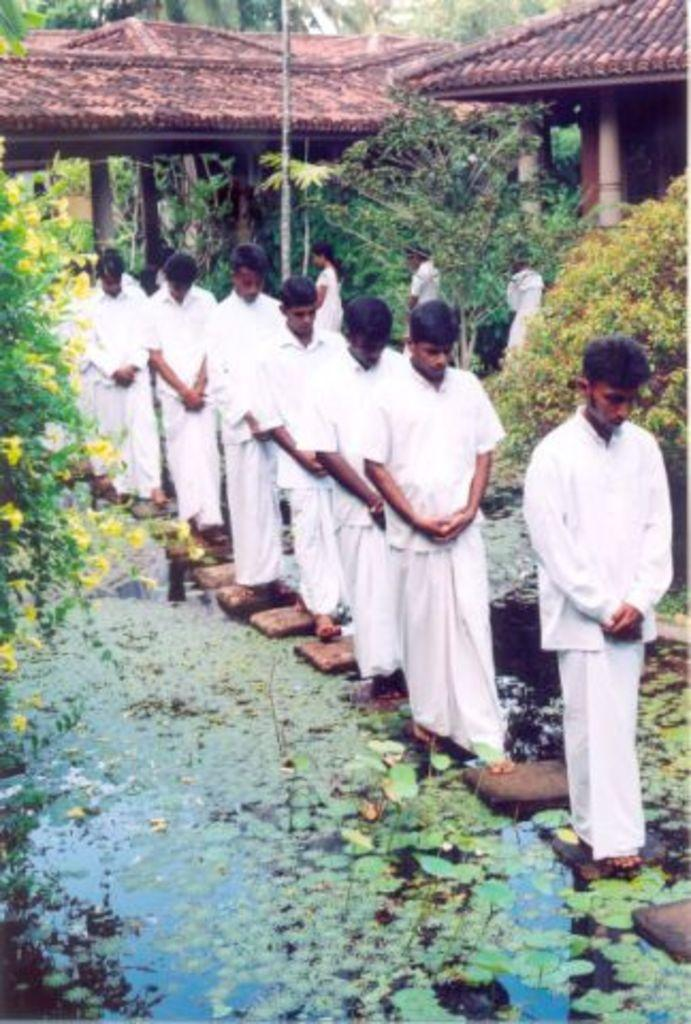How many people can be seen in the image? There are a few people in the image. What is the water in the image containing? The water in the image contains objects and leaves. What type of vegetation is present in the image? There are plants and trees in the image. What structure can be seen in the image? There is a pole in the image. What type of buildings are visible in the image? There are houses in the image. What architectural elements can be seen in the image? There are pillars in the image. What type of sofa can be seen in the image? There is no sofa present in the image. What memories are being evoked by the objects in the water? The image does not provide any information about memories or emotions associated with the objects in the water. 